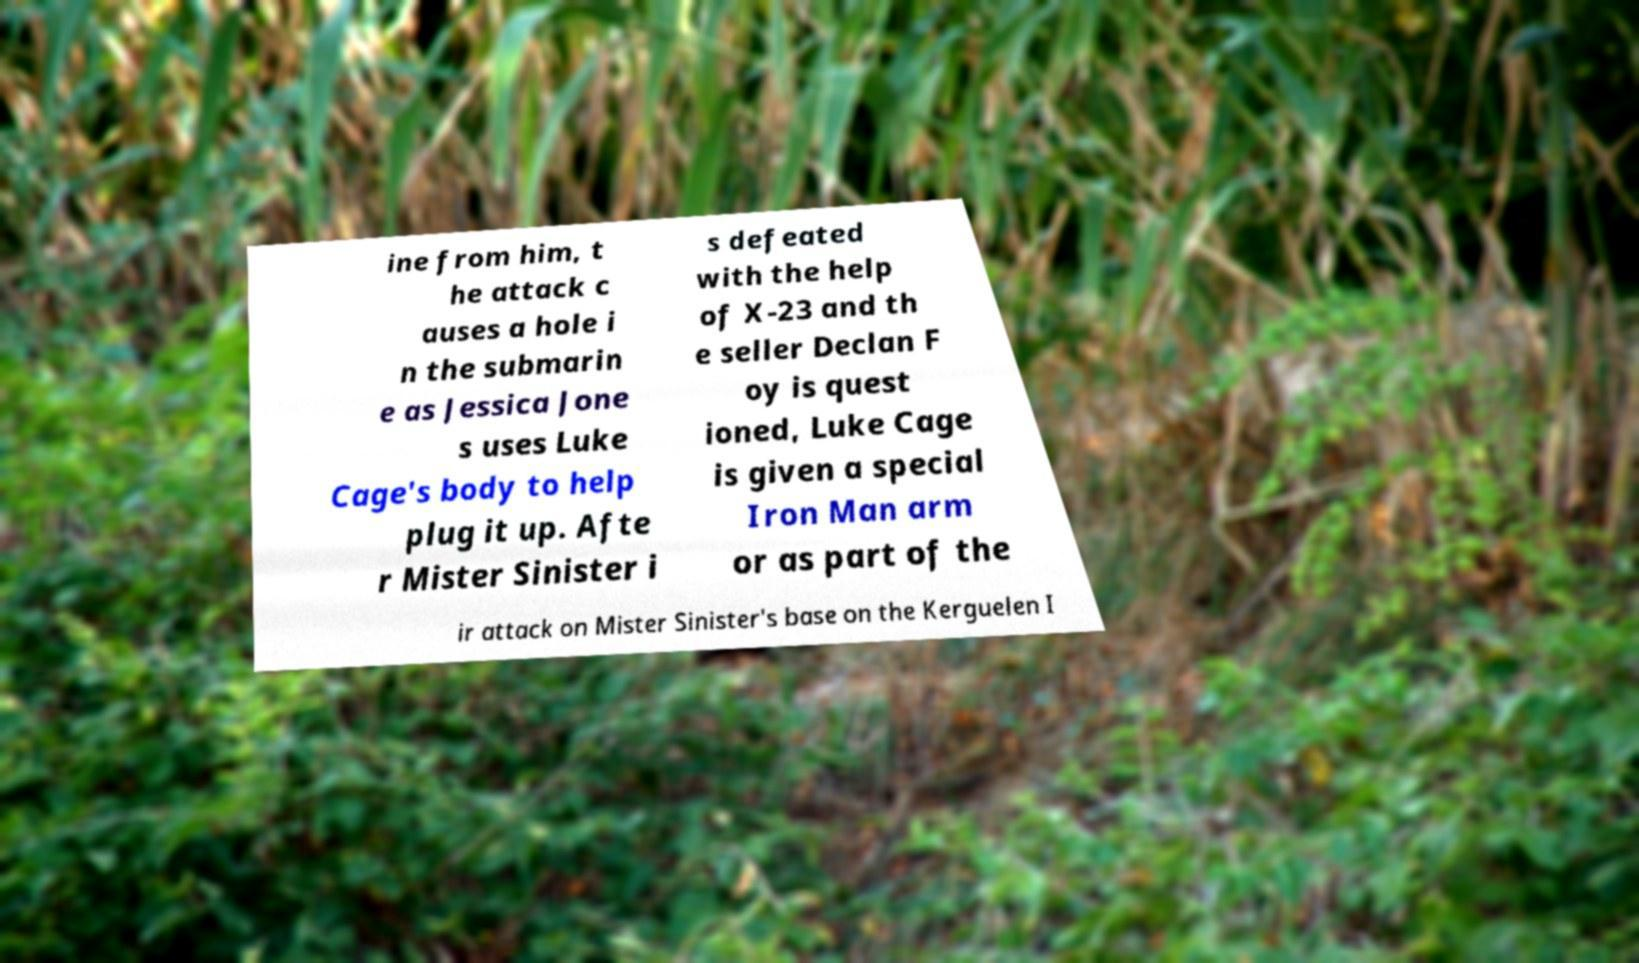Could you assist in decoding the text presented in this image and type it out clearly? ine from him, t he attack c auses a hole i n the submarin e as Jessica Jone s uses Luke Cage's body to help plug it up. Afte r Mister Sinister i s defeated with the help of X-23 and th e seller Declan F oy is quest ioned, Luke Cage is given a special Iron Man arm or as part of the ir attack on Mister Sinister's base on the Kerguelen I 